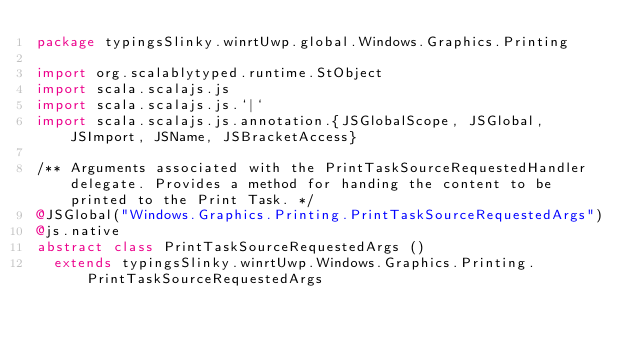<code> <loc_0><loc_0><loc_500><loc_500><_Scala_>package typingsSlinky.winrtUwp.global.Windows.Graphics.Printing

import org.scalablytyped.runtime.StObject
import scala.scalajs.js
import scala.scalajs.js.`|`
import scala.scalajs.js.annotation.{JSGlobalScope, JSGlobal, JSImport, JSName, JSBracketAccess}

/** Arguments associated with the PrintTaskSourceRequestedHandler delegate. Provides a method for handing the content to be printed to the Print Task. */
@JSGlobal("Windows.Graphics.Printing.PrintTaskSourceRequestedArgs")
@js.native
abstract class PrintTaskSourceRequestedArgs ()
  extends typingsSlinky.winrtUwp.Windows.Graphics.Printing.PrintTaskSourceRequestedArgs
</code> 